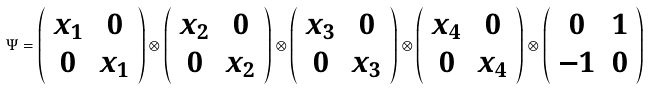Convert formula to latex. <formula><loc_0><loc_0><loc_500><loc_500>\Psi = \left ( \begin{array} { c c } x _ { 1 } & 0 \\ 0 & x _ { 1 } \end{array} \right ) \otimes \left ( \begin{array} { c c } x _ { 2 } & 0 \\ 0 & x _ { 2 } \end{array} \right ) \otimes \left ( \begin{array} { c c } x _ { 3 } & 0 \\ 0 & x _ { 3 } \end{array} \right ) \otimes \left ( \begin{array} { c c } x _ { 4 } & 0 \\ 0 & x _ { 4 } \end{array} \right ) \otimes \left ( \begin{array} { c c } 0 & 1 \\ - 1 & 0 \end{array} \right )</formula> 